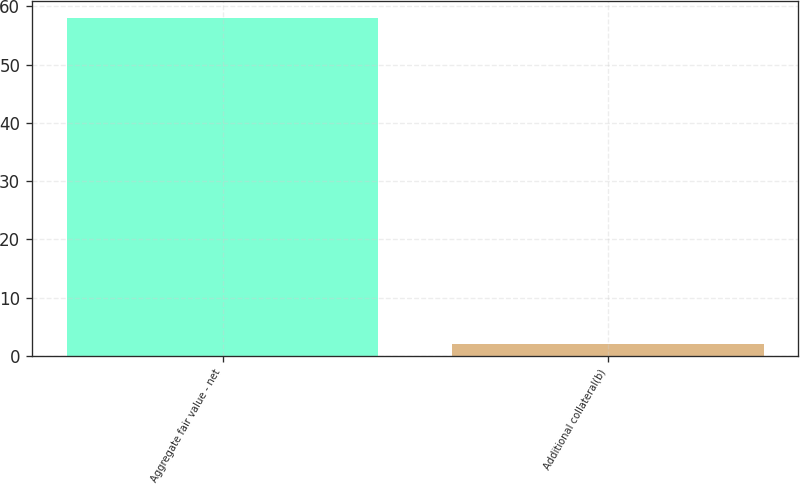Convert chart. <chart><loc_0><loc_0><loc_500><loc_500><bar_chart><fcel>Aggregate fair value - net<fcel>Additional collateral(b)<nl><fcel>58<fcel>2<nl></chart> 